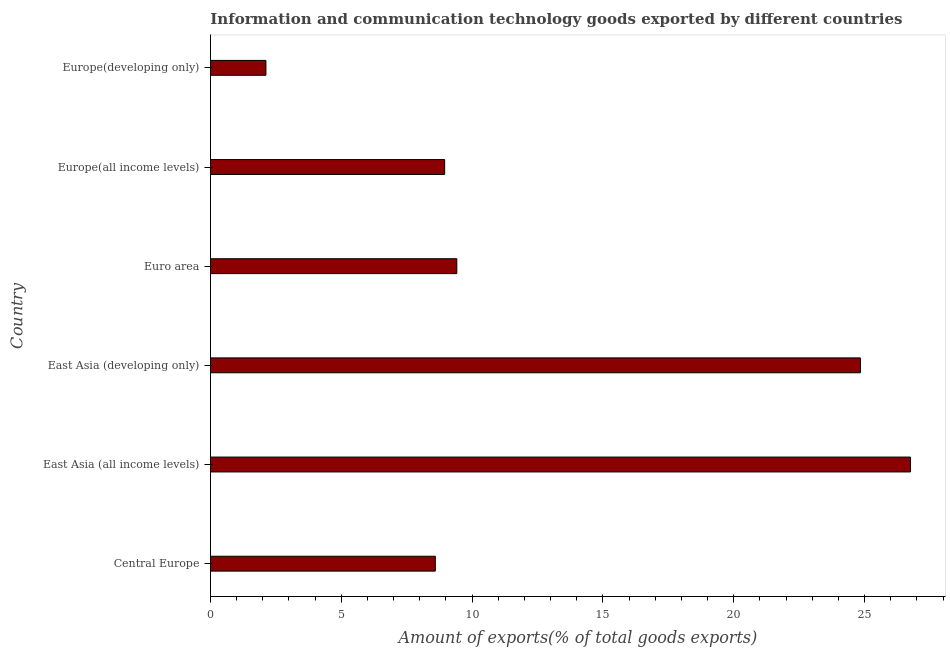Does the graph contain grids?
Give a very brief answer. No. What is the title of the graph?
Your answer should be compact. Information and communication technology goods exported by different countries. What is the label or title of the X-axis?
Your response must be concise. Amount of exports(% of total goods exports). What is the label or title of the Y-axis?
Make the answer very short. Country. What is the amount of ict goods exports in Europe(all income levels)?
Your answer should be very brief. 8.95. Across all countries, what is the maximum amount of ict goods exports?
Your answer should be compact. 26.75. Across all countries, what is the minimum amount of ict goods exports?
Offer a very short reply. 2.12. In which country was the amount of ict goods exports maximum?
Offer a very short reply. East Asia (all income levels). In which country was the amount of ict goods exports minimum?
Keep it short and to the point. Europe(developing only). What is the sum of the amount of ict goods exports?
Your response must be concise. 80.67. What is the difference between the amount of ict goods exports in Central Europe and East Asia (developing only)?
Offer a very short reply. -16.25. What is the average amount of ict goods exports per country?
Your answer should be compact. 13.45. What is the median amount of ict goods exports?
Provide a succinct answer. 9.18. What is the ratio of the amount of ict goods exports in Euro area to that in Europe(all income levels)?
Give a very brief answer. 1.05. What is the difference between the highest and the second highest amount of ict goods exports?
Keep it short and to the point. 1.91. What is the difference between the highest and the lowest amount of ict goods exports?
Offer a very short reply. 24.63. What is the Amount of exports(% of total goods exports) in Central Europe?
Your answer should be very brief. 8.59. What is the Amount of exports(% of total goods exports) in East Asia (all income levels)?
Provide a short and direct response. 26.75. What is the Amount of exports(% of total goods exports) of East Asia (developing only)?
Provide a short and direct response. 24.84. What is the Amount of exports(% of total goods exports) in Euro area?
Provide a succinct answer. 9.41. What is the Amount of exports(% of total goods exports) of Europe(all income levels)?
Your answer should be compact. 8.95. What is the Amount of exports(% of total goods exports) of Europe(developing only)?
Your answer should be compact. 2.12. What is the difference between the Amount of exports(% of total goods exports) in Central Europe and East Asia (all income levels)?
Your answer should be very brief. -18.16. What is the difference between the Amount of exports(% of total goods exports) in Central Europe and East Asia (developing only)?
Offer a terse response. -16.25. What is the difference between the Amount of exports(% of total goods exports) in Central Europe and Euro area?
Your response must be concise. -0.82. What is the difference between the Amount of exports(% of total goods exports) in Central Europe and Europe(all income levels)?
Provide a short and direct response. -0.36. What is the difference between the Amount of exports(% of total goods exports) in Central Europe and Europe(developing only)?
Ensure brevity in your answer.  6.47. What is the difference between the Amount of exports(% of total goods exports) in East Asia (all income levels) and East Asia (developing only)?
Offer a terse response. 1.91. What is the difference between the Amount of exports(% of total goods exports) in East Asia (all income levels) and Euro area?
Give a very brief answer. 17.34. What is the difference between the Amount of exports(% of total goods exports) in East Asia (all income levels) and Europe(all income levels)?
Give a very brief answer. 17.8. What is the difference between the Amount of exports(% of total goods exports) in East Asia (all income levels) and Europe(developing only)?
Offer a terse response. 24.63. What is the difference between the Amount of exports(% of total goods exports) in East Asia (developing only) and Euro area?
Your answer should be compact. 15.43. What is the difference between the Amount of exports(% of total goods exports) in East Asia (developing only) and Europe(all income levels)?
Offer a very short reply. 15.89. What is the difference between the Amount of exports(% of total goods exports) in East Asia (developing only) and Europe(developing only)?
Your answer should be very brief. 22.72. What is the difference between the Amount of exports(% of total goods exports) in Euro area and Europe(all income levels)?
Keep it short and to the point. 0.46. What is the difference between the Amount of exports(% of total goods exports) in Euro area and Europe(developing only)?
Give a very brief answer. 7.3. What is the difference between the Amount of exports(% of total goods exports) in Europe(all income levels) and Europe(developing only)?
Ensure brevity in your answer.  6.83. What is the ratio of the Amount of exports(% of total goods exports) in Central Europe to that in East Asia (all income levels)?
Give a very brief answer. 0.32. What is the ratio of the Amount of exports(% of total goods exports) in Central Europe to that in East Asia (developing only)?
Ensure brevity in your answer.  0.35. What is the ratio of the Amount of exports(% of total goods exports) in Central Europe to that in Europe(developing only)?
Your answer should be very brief. 4.05. What is the ratio of the Amount of exports(% of total goods exports) in East Asia (all income levels) to that in East Asia (developing only)?
Provide a succinct answer. 1.08. What is the ratio of the Amount of exports(% of total goods exports) in East Asia (all income levels) to that in Euro area?
Provide a short and direct response. 2.84. What is the ratio of the Amount of exports(% of total goods exports) in East Asia (all income levels) to that in Europe(all income levels)?
Offer a very short reply. 2.99. What is the ratio of the Amount of exports(% of total goods exports) in East Asia (all income levels) to that in Europe(developing only)?
Your answer should be very brief. 12.63. What is the ratio of the Amount of exports(% of total goods exports) in East Asia (developing only) to that in Euro area?
Your response must be concise. 2.64. What is the ratio of the Amount of exports(% of total goods exports) in East Asia (developing only) to that in Europe(all income levels)?
Your answer should be very brief. 2.77. What is the ratio of the Amount of exports(% of total goods exports) in East Asia (developing only) to that in Europe(developing only)?
Offer a very short reply. 11.72. What is the ratio of the Amount of exports(% of total goods exports) in Euro area to that in Europe(all income levels)?
Your response must be concise. 1.05. What is the ratio of the Amount of exports(% of total goods exports) in Euro area to that in Europe(developing only)?
Your answer should be very brief. 4.44. What is the ratio of the Amount of exports(% of total goods exports) in Europe(all income levels) to that in Europe(developing only)?
Provide a short and direct response. 4.22. 